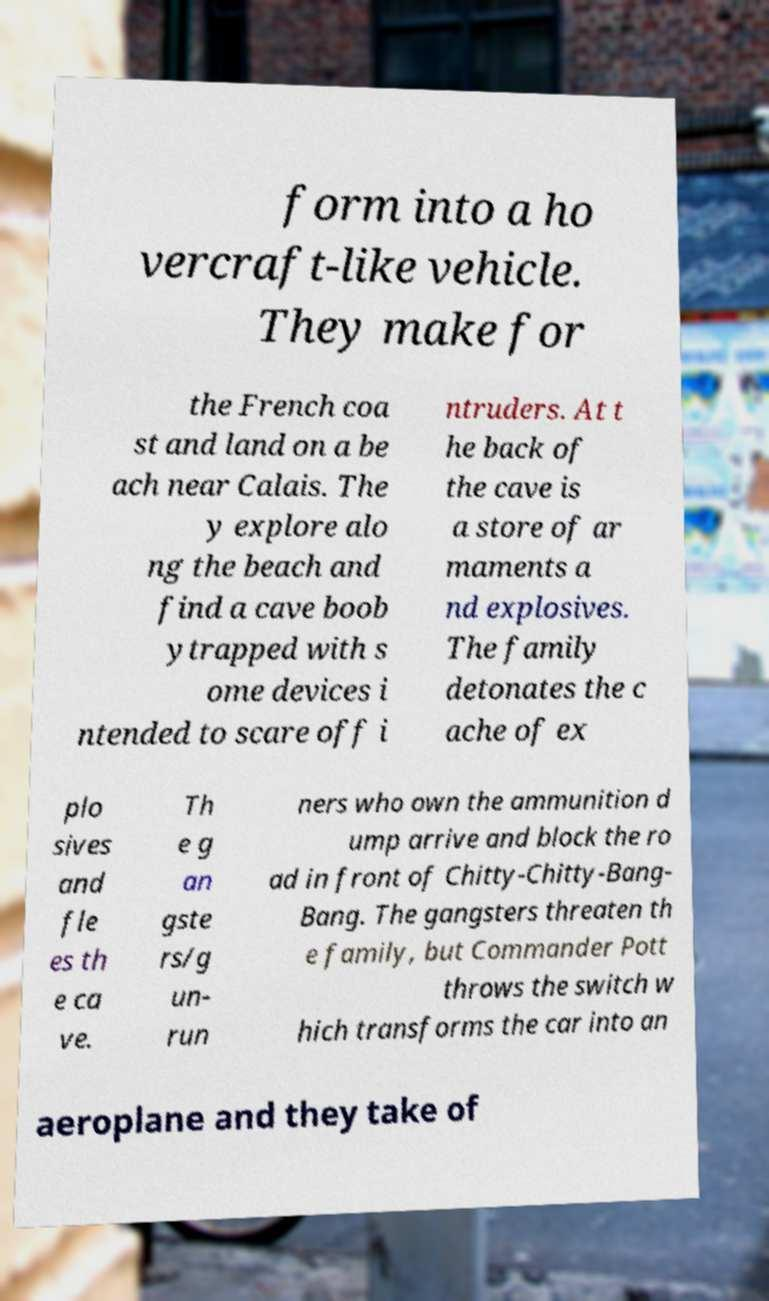Could you assist in decoding the text presented in this image and type it out clearly? form into a ho vercraft-like vehicle. They make for the French coa st and land on a be ach near Calais. The y explore alo ng the beach and find a cave boob ytrapped with s ome devices i ntended to scare off i ntruders. At t he back of the cave is a store of ar maments a nd explosives. The family detonates the c ache of ex plo sives and fle es th e ca ve. Th e g an gste rs/g un- run ners who own the ammunition d ump arrive and block the ro ad in front of Chitty-Chitty-Bang- Bang. The gangsters threaten th e family, but Commander Pott throws the switch w hich transforms the car into an aeroplane and they take of 